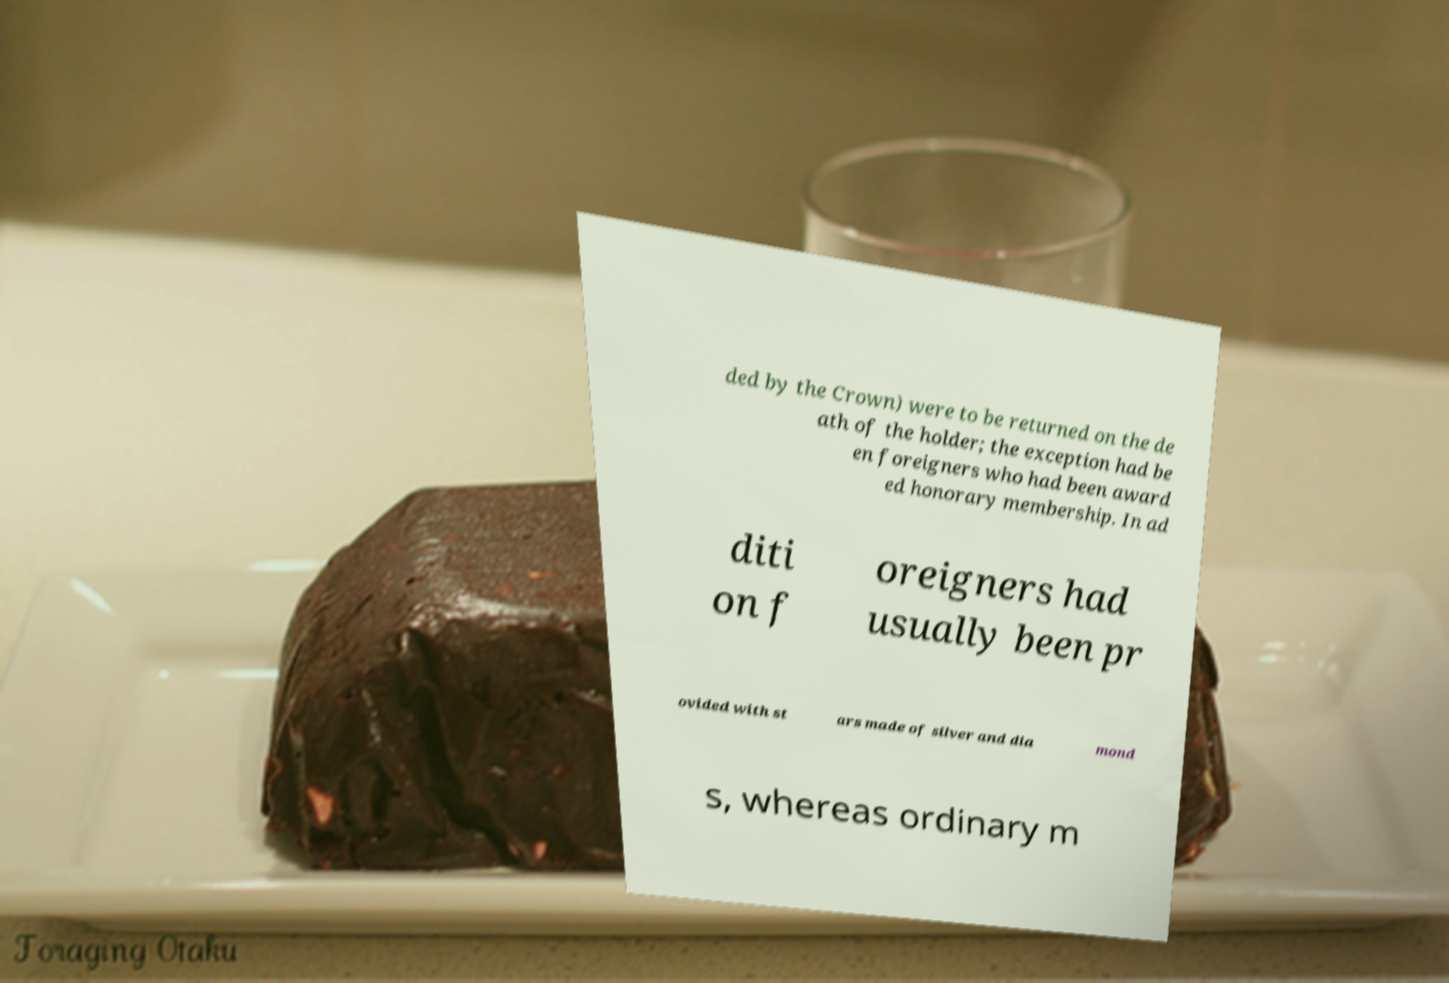What messages or text are displayed in this image? I need them in a readable, typed format. ded by the Crown) were to be returned on the de ath of the holder; the exception had be en foreigners who had been award ed honorary membership. In ad diti on f oreigners had usually been pr ovided with st ars made of silver and dia mond s, whereas ordinary m 